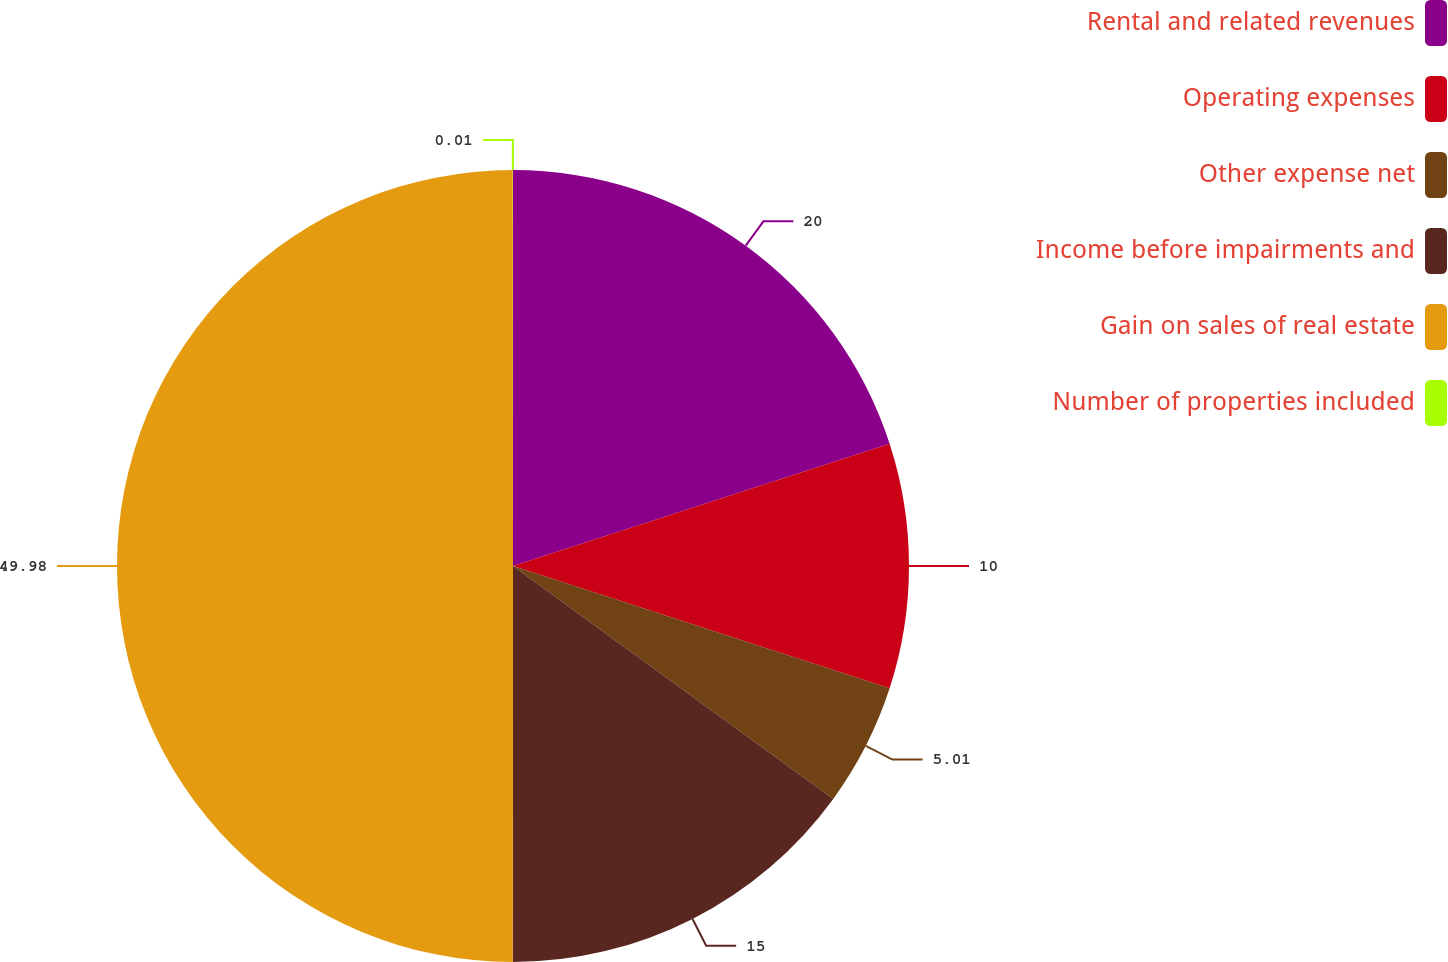Convert chart to OTSL. <chart><loc_0><loc_0><loc_500><loc_500><pie_chart><fcel>Rental and related revenues<fcel>Operating expenses<fcel>Other expense net<fcel>Income before impairments and<fcel>Gain on sales of real estate<fcel>Number of properties included<nl><fcel>20.0%<fcel>10.0%<fcel>5.01%<fcel>15.0%<fcel>49.98%<fcel>0.01%<nl></chart> 